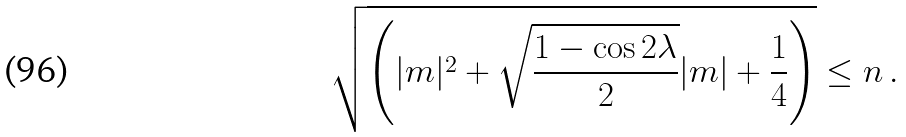<formula> <loc_0><loc_0><loc_500><loc_500>\sqrt { \left ( | m | ^ { 2 } + \sqrt { \frac { 1 - \cos 2 \lambda } { 2 } } | m | + \frac { 1 } { 4 } \right ) } \leq n \, .</formula> 